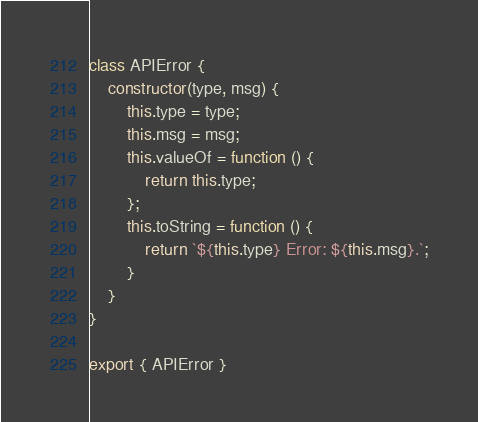<code> <loc_0><loc_0><loc_500><loc_500><_JavaScript_>class APIError {
    constructor(type, msg) {
        this.type = type;
        this.msg = msg;
        this.valueOf = function () {
            return this.type;
        };
        this.toString = function () {
            return `${this.type} Error: ${this.msg}.`;
        }
    }
}

export { APIError }</code> 